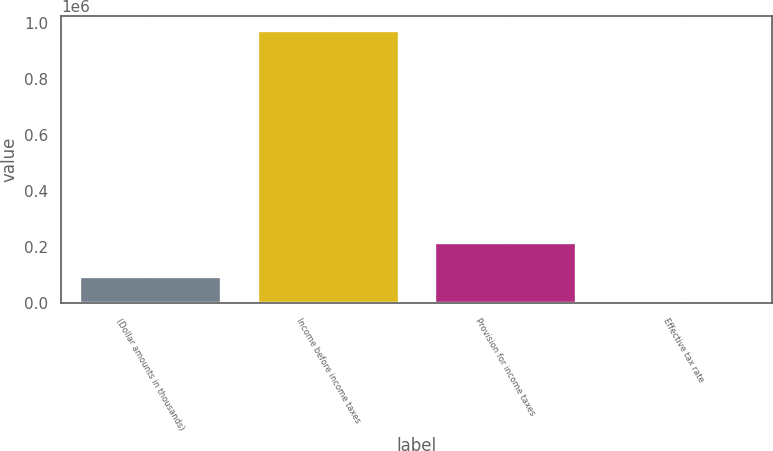<chart> <loc_0><loc_0><loc_500><loc_500><bar_chart><fcel>(Dollar amounts in thousands)<fcel>Income before income taxes<fcel>Provision for income taxes<fcel>Effective tax rate<nl><fcel>97429.6<fcel>974094<fcel>218079<fcel>22.4<nl></chart> 